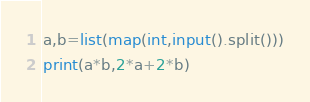<code> <loc_0><loc_0><loc_500><loc_500><_Python_>a,b=list(map(int,input().split()))
print(a*b,2*a+2*b)
</code> 